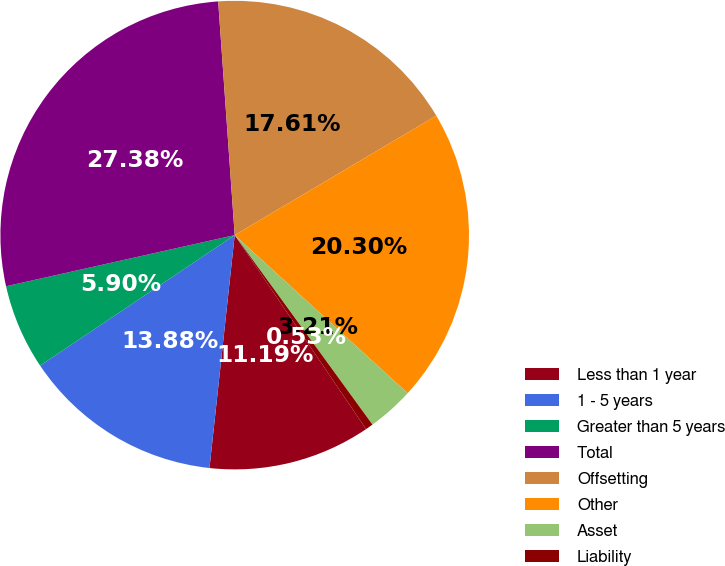Convert chart to OTSL. <chart><loc_0><loc_0><loc_500><loc_500><pie_chart><fcel>Less than 1 year<fcel>1 - 5 years<fcel>Greater than 5 years<fcel>Total<fcel>Offsetting<fcel>Other<fcel>Asset<fcel>Liability<nl><fcel>11.19%<fcel>13.88%<fcel>5.9%<fcel>27.38%<fcel>17.61%<fcel>20.3%<fcel>3.21%<fcel>0.53%<nl></chart> 